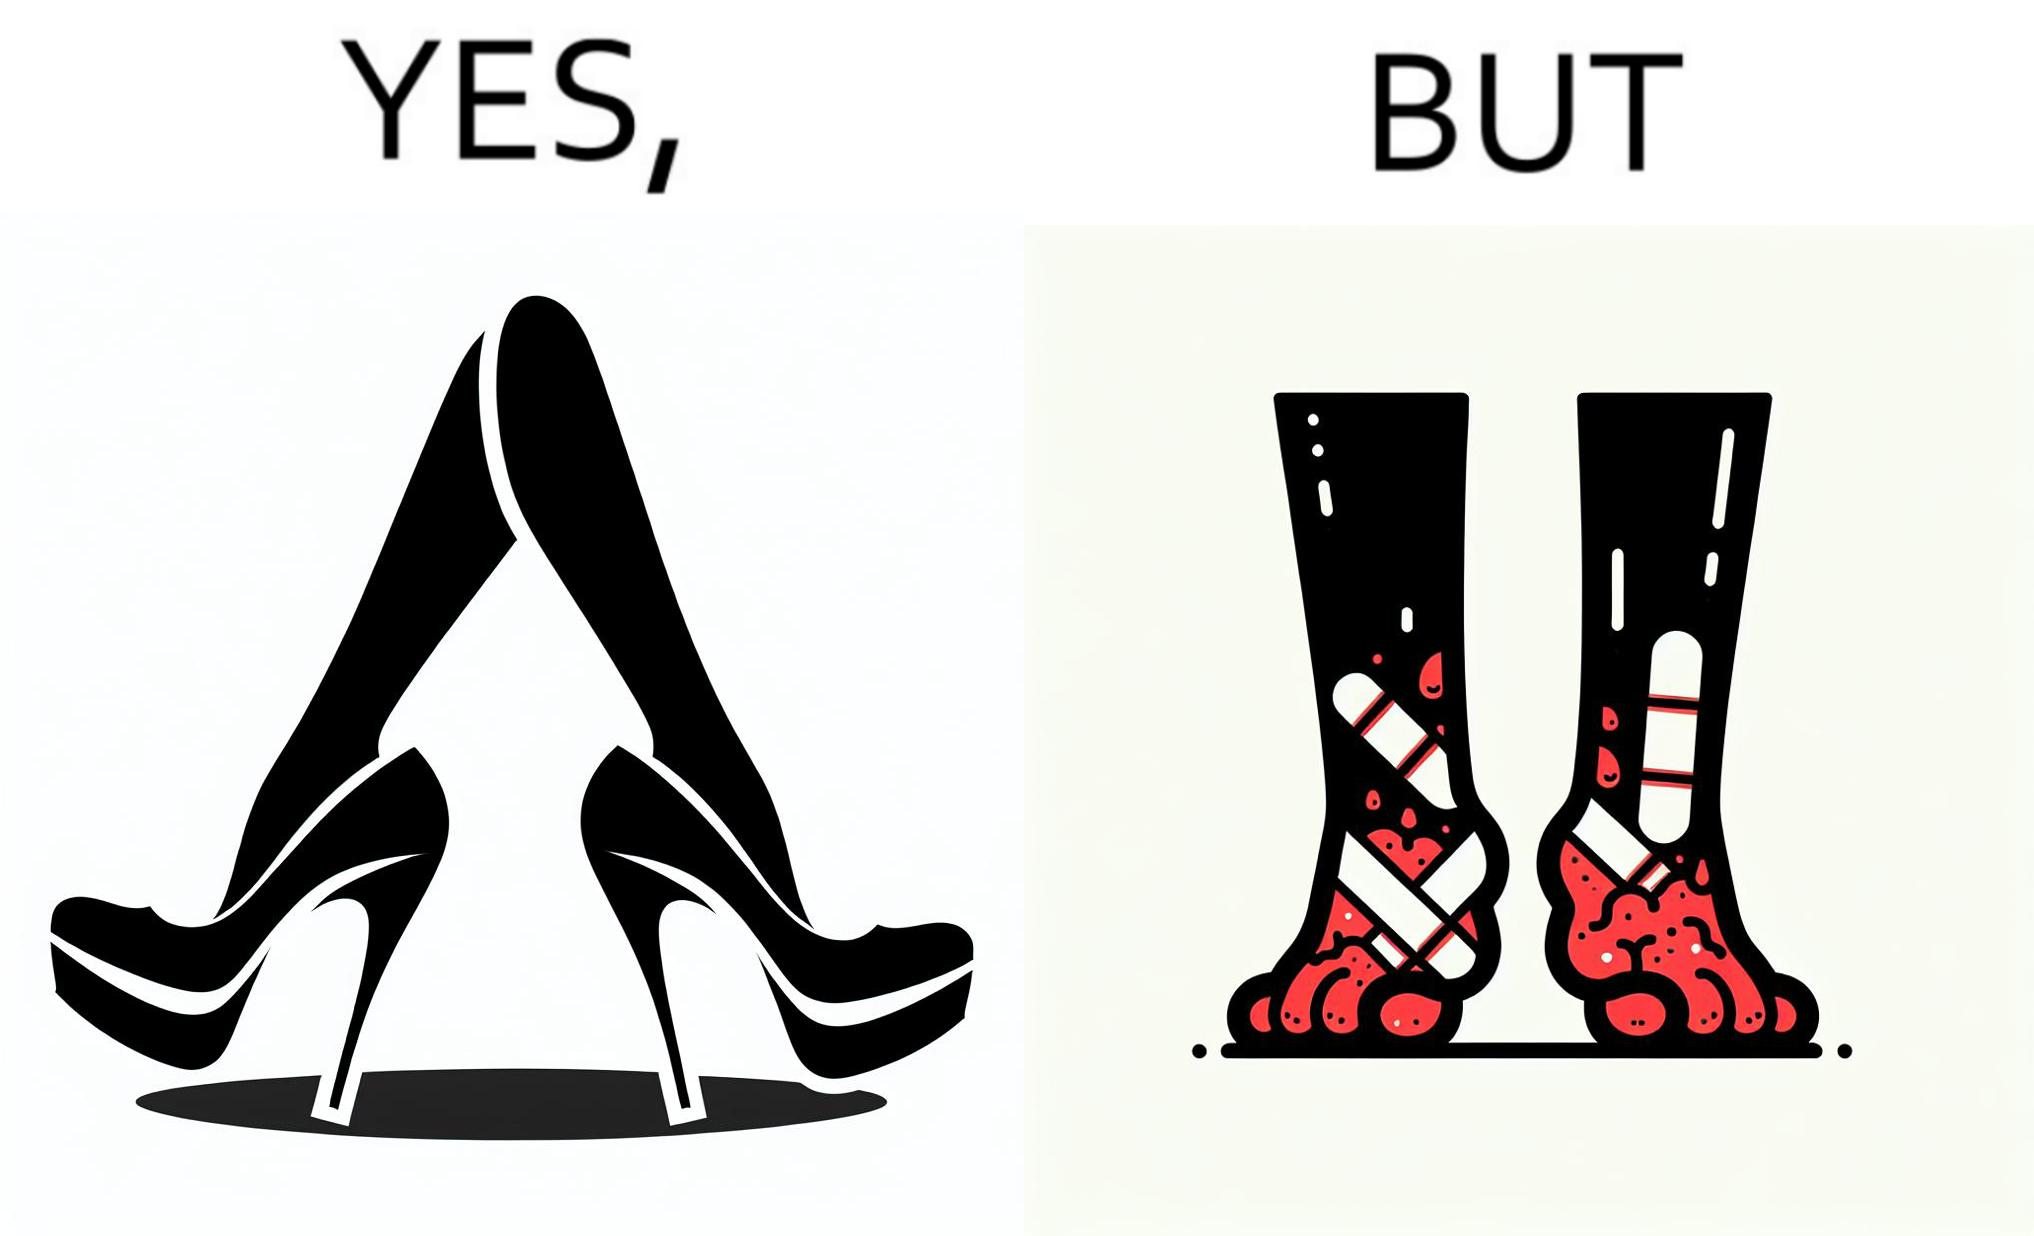What is the satirical meaning behind this image? The images are funny since they show how the prettiest footwears like high heels, end up causing a lot of physical discomfort to the user, all in the name fashion 